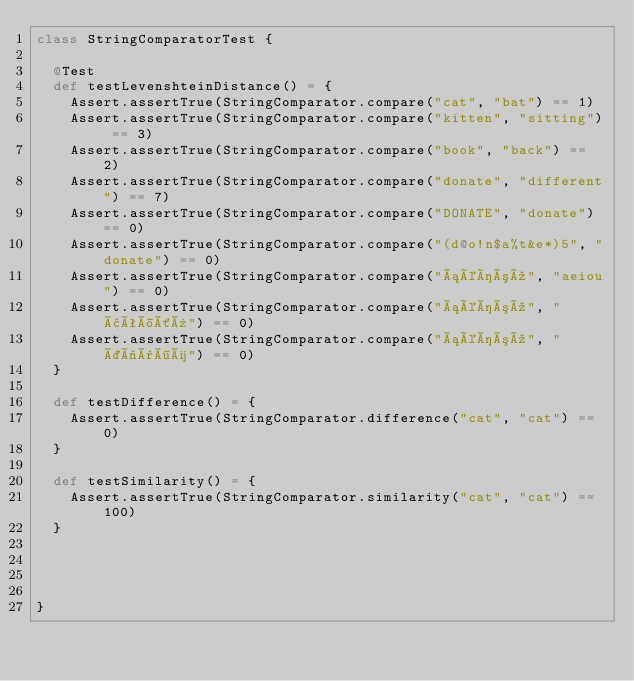<code> <loc_0><loc_0><loc_500><loc_500><_Scala_>class StringComparatorTest {

  @Test
  def testLevenshteinDistance() = {
    Assert.assertTrue(StringComparator.compare("cat", "bat") == 1)
    Assert.assertTrue(StringComparator.compare("kitten", "sitting") == 3)
    Assert.assertTrue(StringComparator.compare("book", "back") == 2)
    Assert.assertTrue(StringComparator.compare("donate", "different") == 7)
    Assert.assertTrue(StringComparator.compare("DONATE", "donate") == 0)
    Assert.assertTrue(StringComparator.compare("(d@o!n$a%t&e*)5", "donate") == 0)
    Assert.assertTrue(StringComparator.compare("áéíóú", "aeiou") == 0)
    Assert.assertTrue(StringComparator.compare("áéíóú", "âêîôû") == 0)
    Assert.assertTrue(StringComparator.compare("áéíóú", "äëïöü") == 0)
  }

  def testDifference() = {
    Assert.assertTrue(StringComparator.difference("cat", "cat") == 0)
  }

  def testSimilarity() = {
    Assert.assertTrue(StringComparator.similarity("cat", "cat") == 100)
  }




}
</code> 